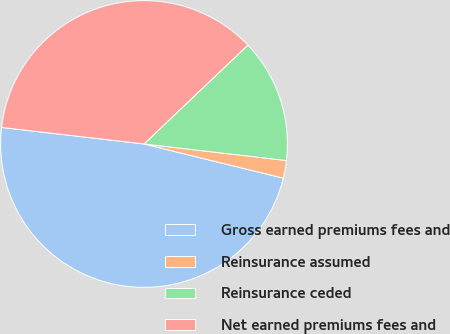Convert chart. <chart><loc_0><loc_0><loc_500><loc_500><pie_chart><fcel>Gross earned premiums fees and<fcel>Reinsurance assumed<fcel>Reinsurance ceded<fcel>Net earned premiums fees and<nl><fcel>48.01%<fcel>1.99%<fcel>13.95%<fcel>36.05%<nl></chart> 